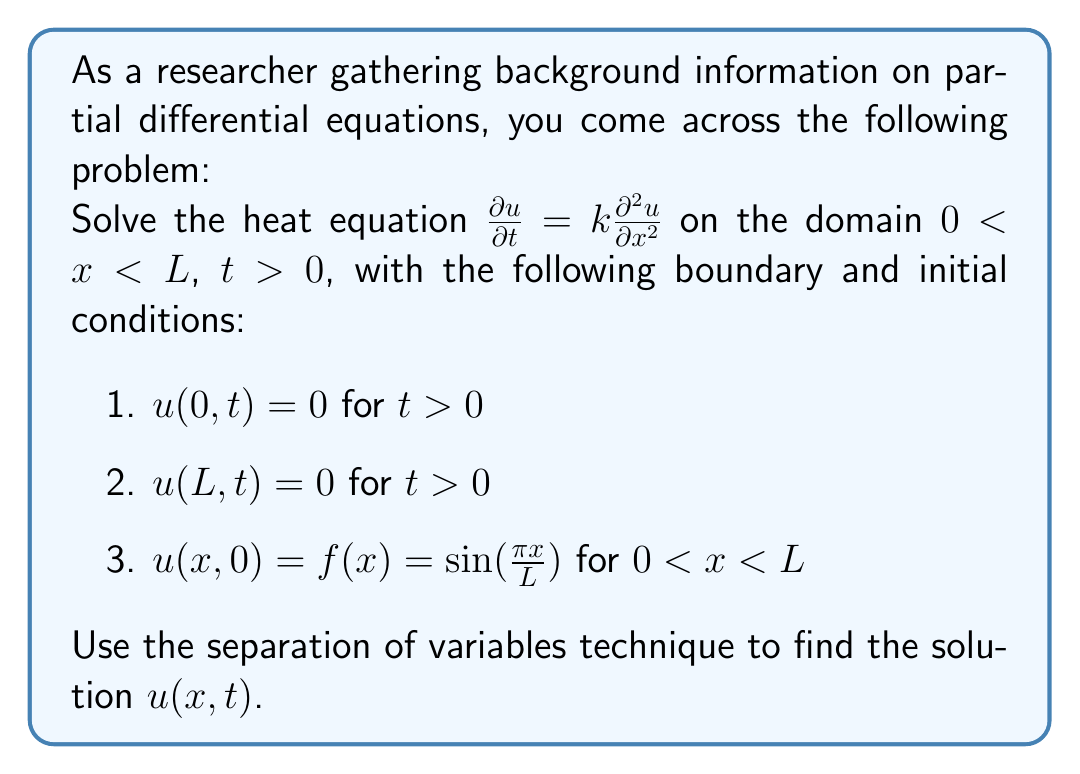Give your solution to this math problem. To solve this partial differential equation using the separation of variables technique, we follow these steps:

1) Assume the solution has the form $u(x,t) = X(x)T(t)$.

2) Substitute this into the PDE:

   $X(x)T'(t) = kX''(x)T(t)$

3) Divide both sides by $X(x)T(t)$:

   $\frac{T'(t)}{T(t)} = k\frac{X''(x)}{X(x)} = -\lambda$

   Where $-\lambda$ is a separation constant.

4) This gives us two ODEs:
   
   $T'(t) + \lambda kT(t) = 0$
   $X''(x) + \lambda X(x) = 0$

5) Solve the spatial ODE $X''(x) + \lambda X(x) = 0$ with boundary conditions:
   
   $X(0) = 0$ and $X(L) = 0$

   This gives the eigenvalue problem with solutions:

   $X_n(x) = \sin(\frac{n\pi x}{L})$, where $\lambda_n = (\frac{n\pi}{L})^2$, $n = 1,2,3,...$

6) Solve the temporal ODE $T'(t) + \lambda k T(t) = 0$:

   $T_n(t) = e^{-k(\frac{n\pi}{L})^2t}$

7) The general solution is:

   $u(x,t) = \sum_{n=1}^{\infty} A_n \sin(\frac{n\pi x}{L})e^{-k(\frac{n\pi}{L})^2t}$

8) Apply the initial condition $u(x,0) = f(x) = \sin(\frac{\pi x}{L})$:

   $\sum_{n=1}^{\infty} A_n \sin(\frac{n\pi x}{L}) = \sin(\frac{\pi x}{L})$

9) This implies $A_1 = 1$ and $A_n = 0$ for $n > 1$.

Therefore, the final solution is:

$u(x,t) = \sin(\frac{\pi x}{L})e^{-k(\frac{\pi}{L})^2t}$
Answer: $u(x,t) = \sin(\frac{\pi x}{L})e^{-k(\frac{\pi}{L})^2t}$ 